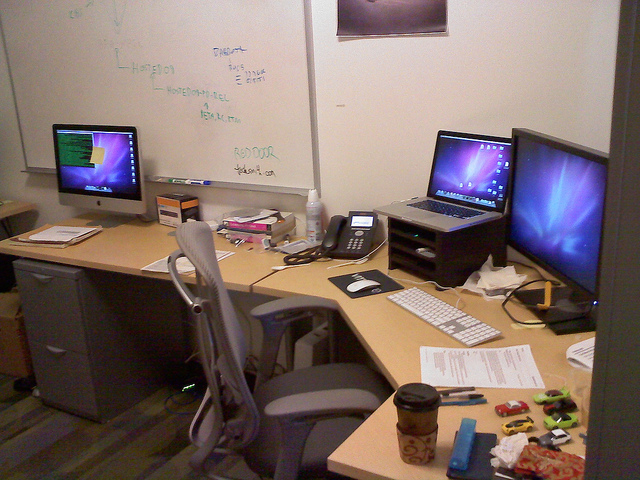<image>What book is laying on the desk? I don't know what book is laying on the desk. It may be a text book or a manual. What book is laying on the desk? It is ambiguous what book is laying on the desk. It can be seen 'text', 'manual', 'medical', 'notebook', 'phonebook', 'science' or 'telephone book'. 